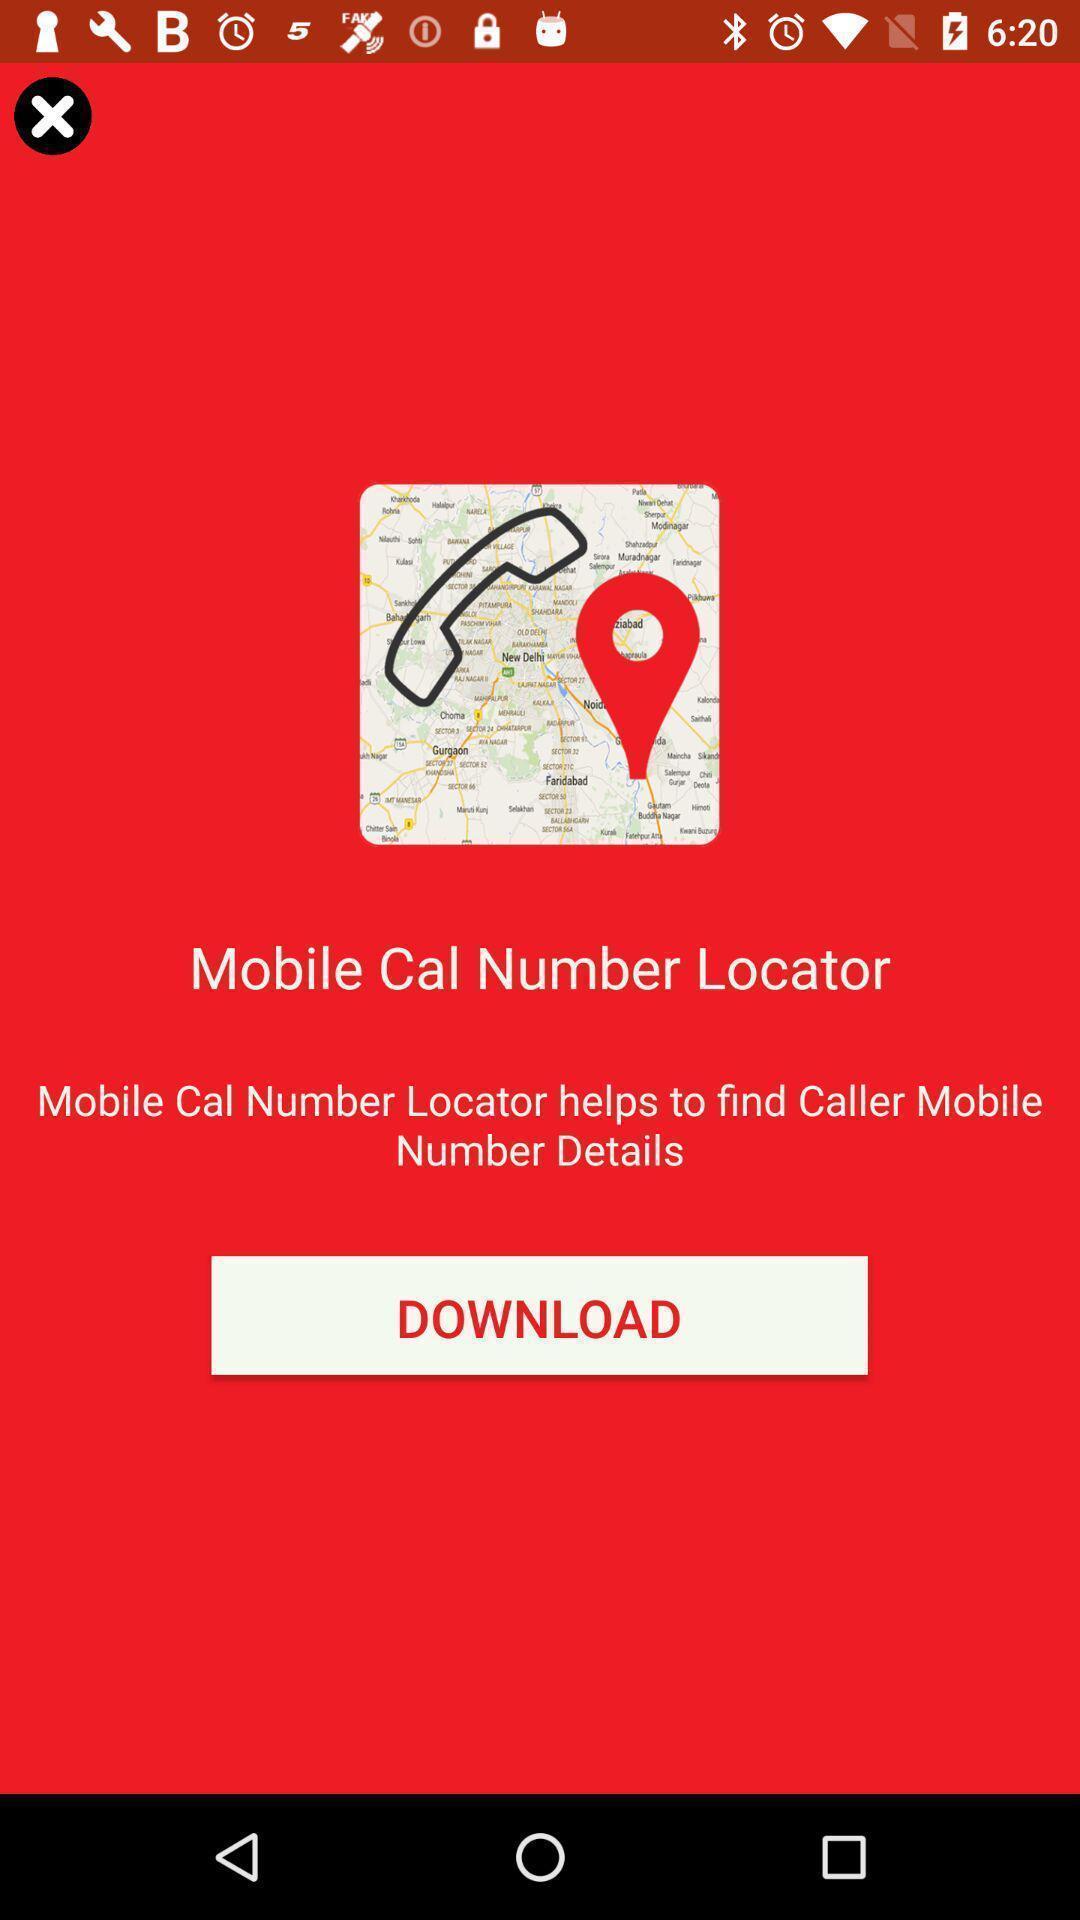Describe this image in words. Screen with a button to download the app. 